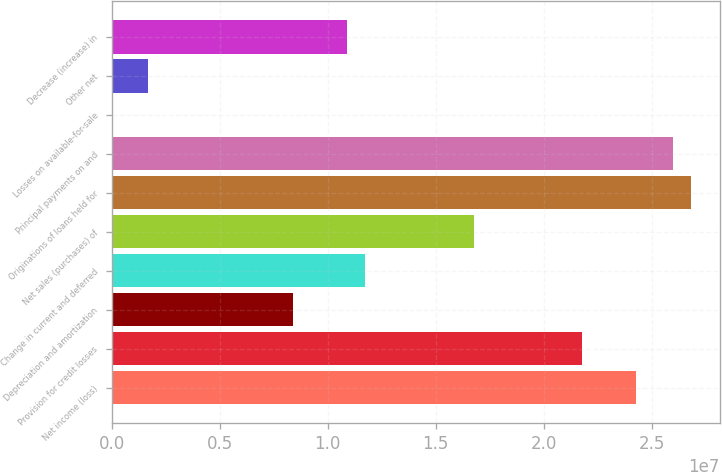<chart> <loc_0><loc_0><loc_500><loc_500><bar_chart><fcel>Net income (loss)<fcel>Provision for credit losses<fcel>Depreciation and amortization<fcel>Change in current and deferred<fcel>Net sales (purchases) of<fcel>Originations of loans held for<fcel>Principal payments on and<fcel>Losses on available-for-sale<fcel>Other net<fcel>Decrease (increase) in<nl><fcel>2.43006e+07<fcel>2.17878e+07<fcel>8.38622e+06<fcel>1.17366e+07<fcel>1.67622e+07<fcel>2.68134e+07<fcel>2.59758e+07<fcel>10249<fcel>1.68544e+06<fcel>1.0899e+07<nl></chart> 